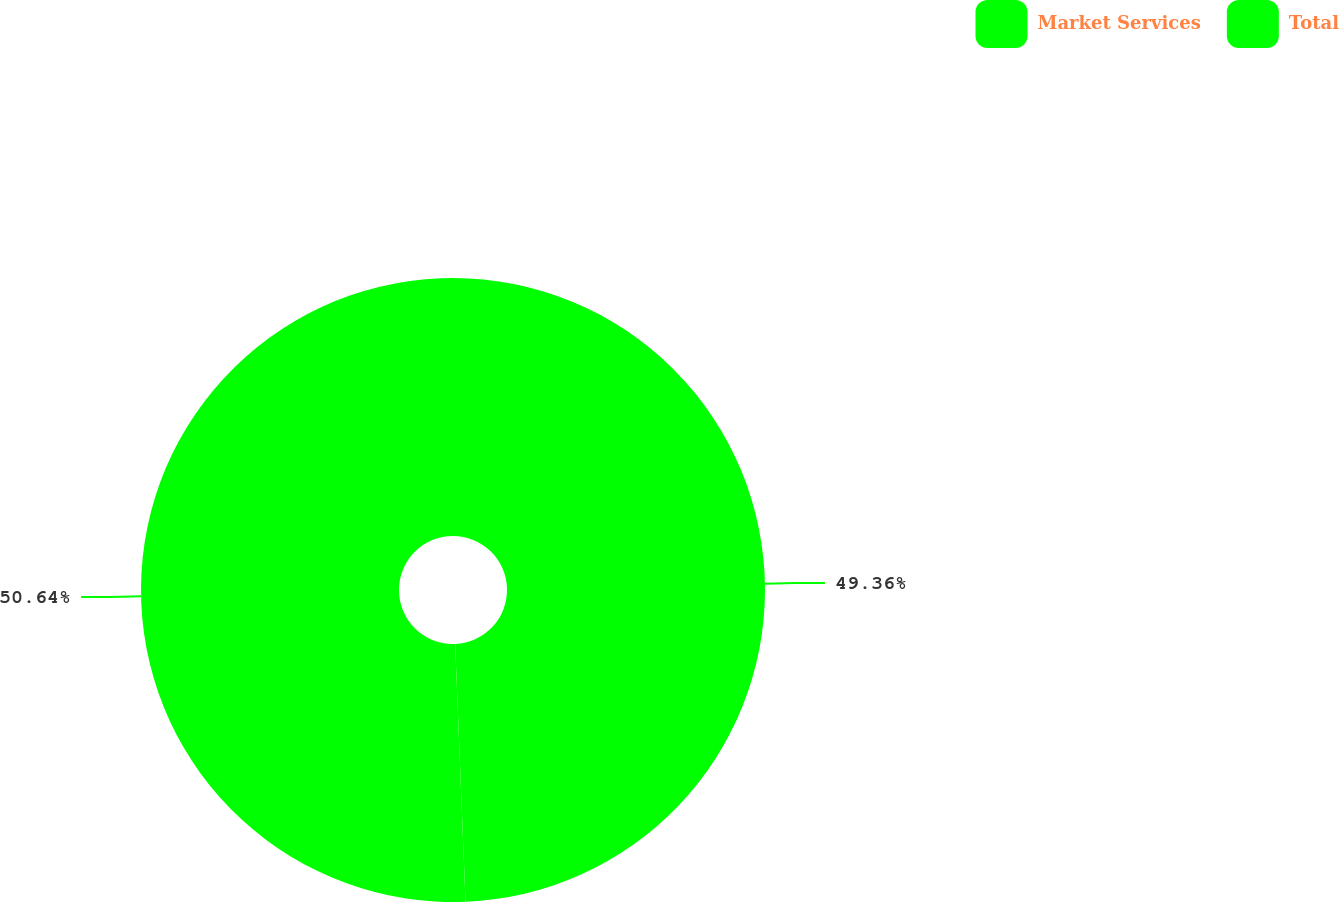<chart> <loc_0><loc_0><loc_500><loc_500><pie_chart><fcel>Market Services<fcel>Total<nl><fcel>49.36%<fcel>50.64%<nl></chart> 